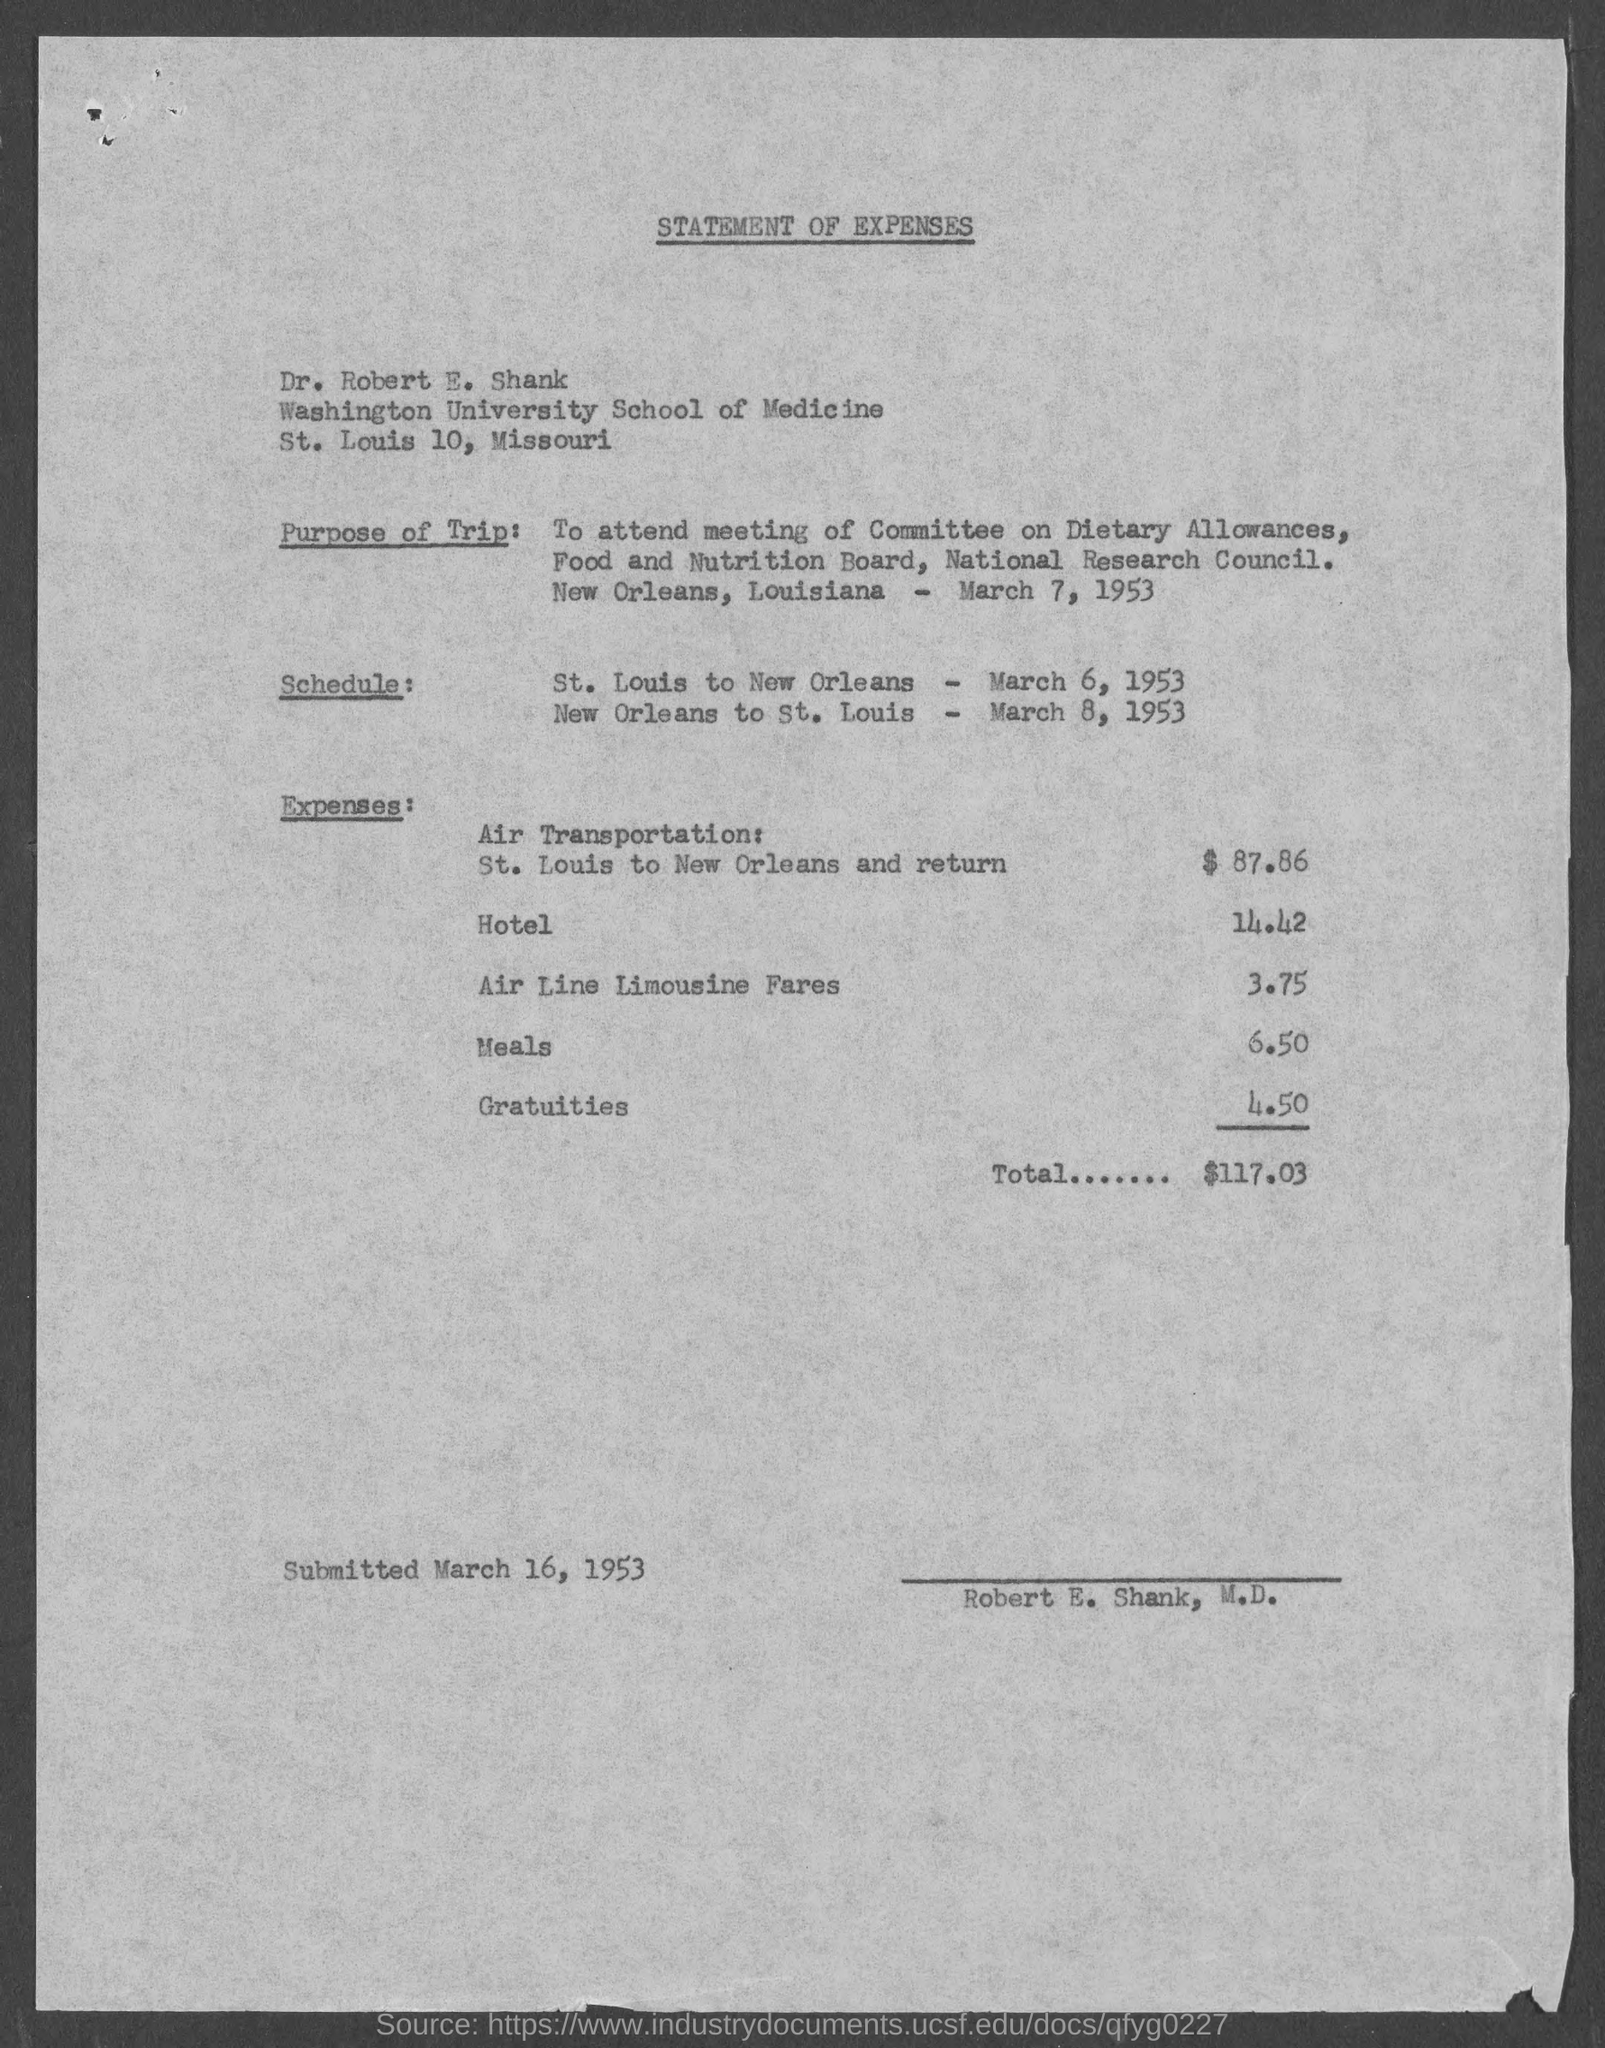What is the date mentioned in the bottom of the document ?
Provide a short and direct response. March 16, 1953. 